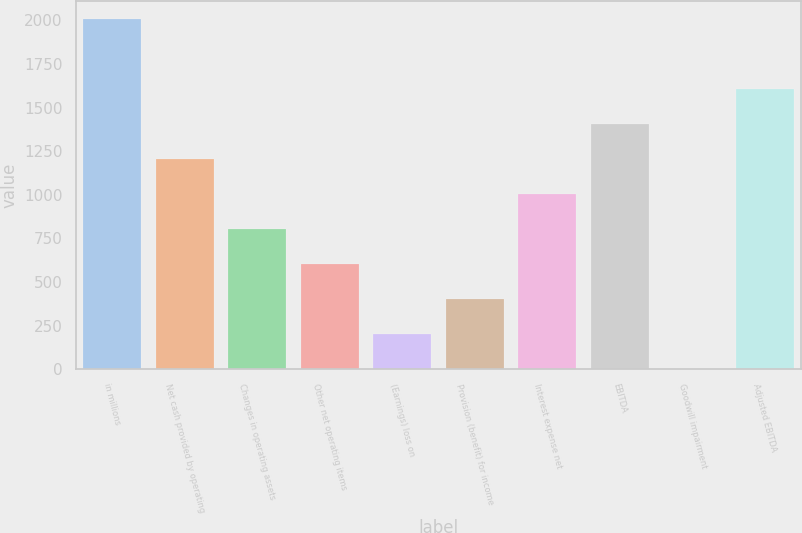Convert chart to OTSL. <chart><loc_0><loc_0><loc_500><loc_500><bar_chart><fcel>in millions<fcel>Net cash provided by operating<fcel>Changes in operating assets<fcel>Other net operating items<fcel>(Earnings) loss on<fcel>Provision (benefit) for income<fcel>Interest expense net<fcel>EBITDA<fcel>Goodwill impairment<fcel>Adjusted EBITDA<nl><fcel>2009<fcel>1205.82<fcel>804.22<fcel>603.42<fcel>201.82<fcel>402.62<fcel>1005.02<fcel>1406.62<fcel>1.02<fcel>1607.42<nl></chart> 